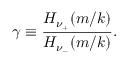<formula> <loc_0><loc_0><loc_500><loc_500>\gamma \equiv \frac { H _ { \nu _ { + } } ( m / k ) } { H _ { \nu _ { - } } ( m / k ) } .</formula> 